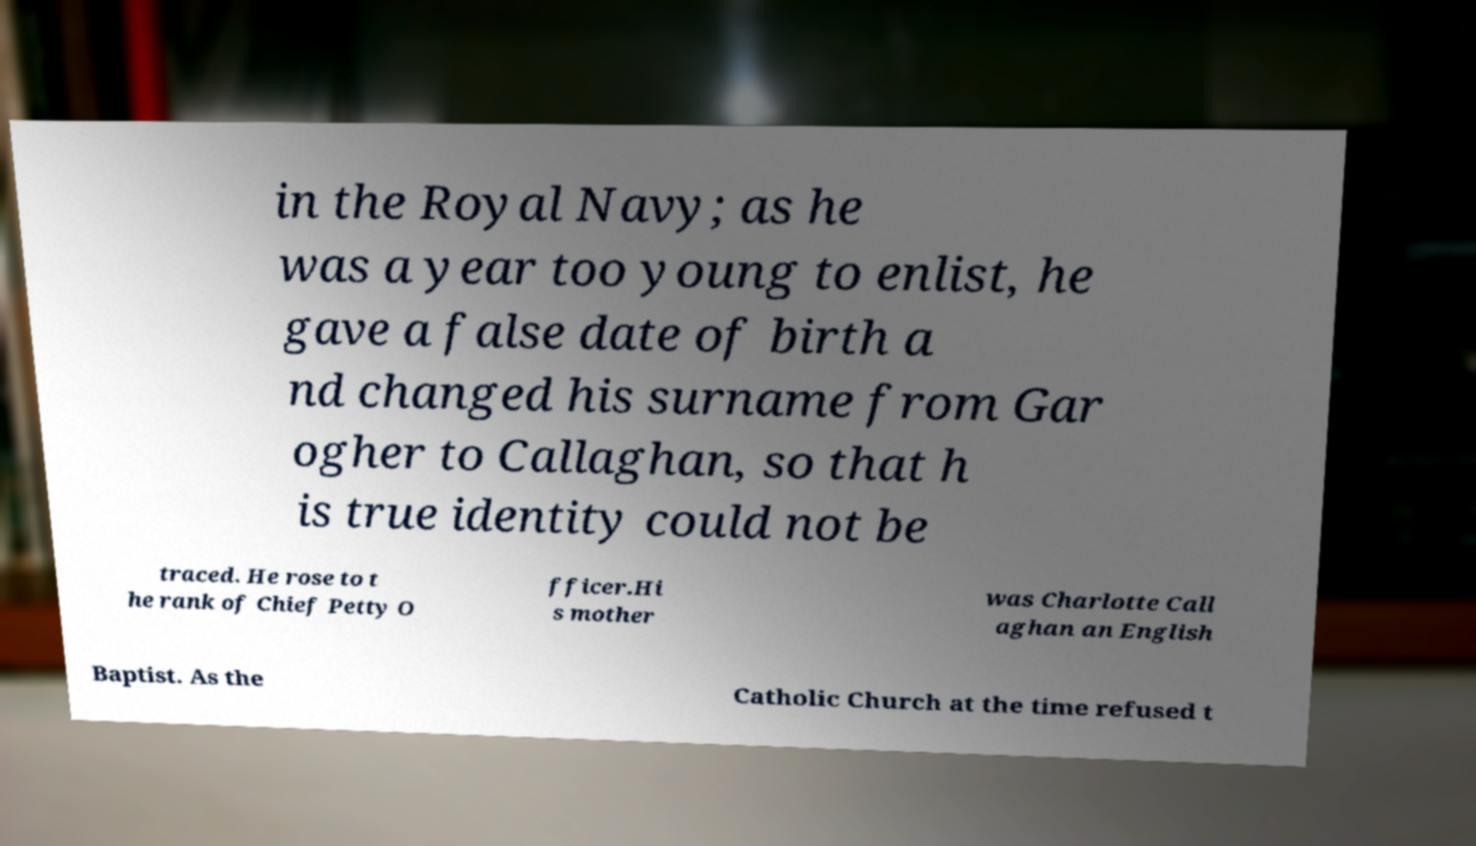What messages or text are displayed in this image? I need them in a readable, typed format. in the Royal Navy; as he was a year too young to enlist, he gave a false date of birth a nd changed his surname from Gar ogher to Callaghan, so that h is true identity could not be traced. He rose to t he rank of Chief Petty O fficer.Hi s mother was Charlotte Call aghan an English Baptist. As the Catholic Church at the time refused t 